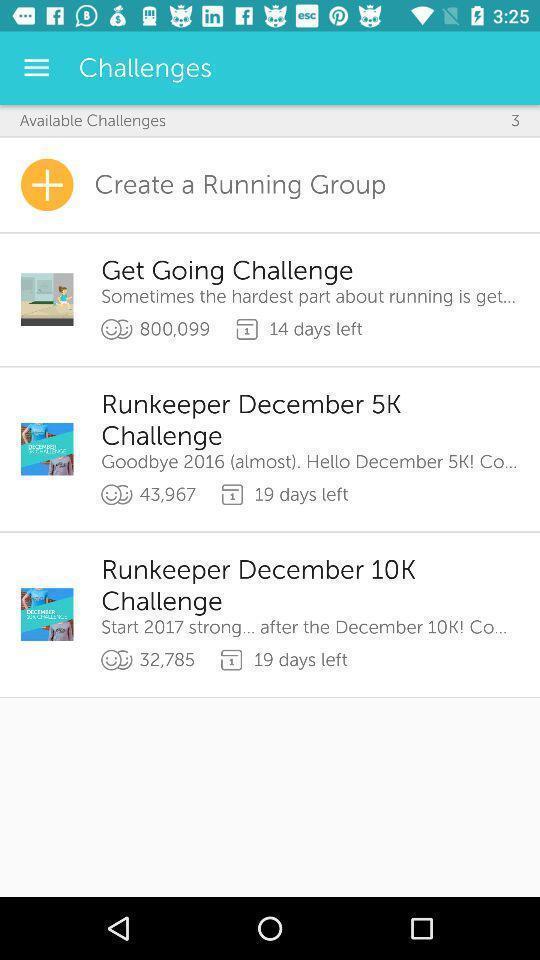Give me a summary of this screen capture. Page showing about different challenges with create option. 